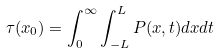<formula> <loc_0><loc_0><loc_500><loc_500>\tau ( x _ { 0 } ) = \int _ { 0 } ^ { \infty } \int _ { - L } ^ { L } P ( x , t ) d x d t</formula> 